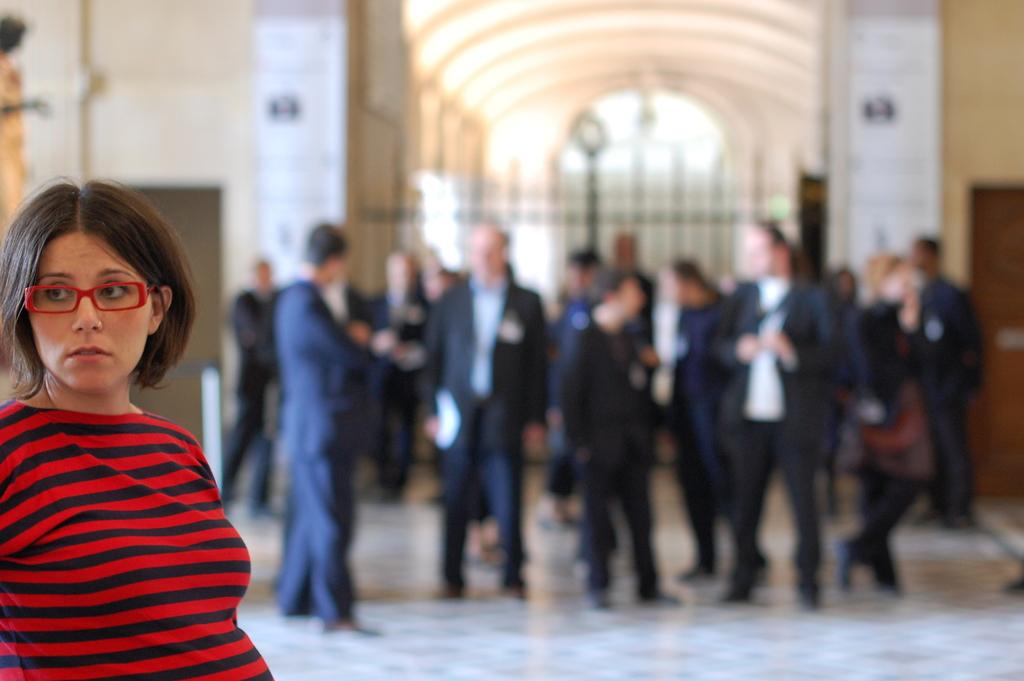What is the main subject of the image? The main subject of the image is a group of people. Where are the people located in the image? The group of people is in a hall. Can you describe the position of a specific person in the image? There is a woman on the left side of the image. What type of boat can be seen in the image? There is no boat present in the image; it features a group of people in a hall. What brand of soda is being served at the event in the image? There is no indication of any soda being served in the image. 